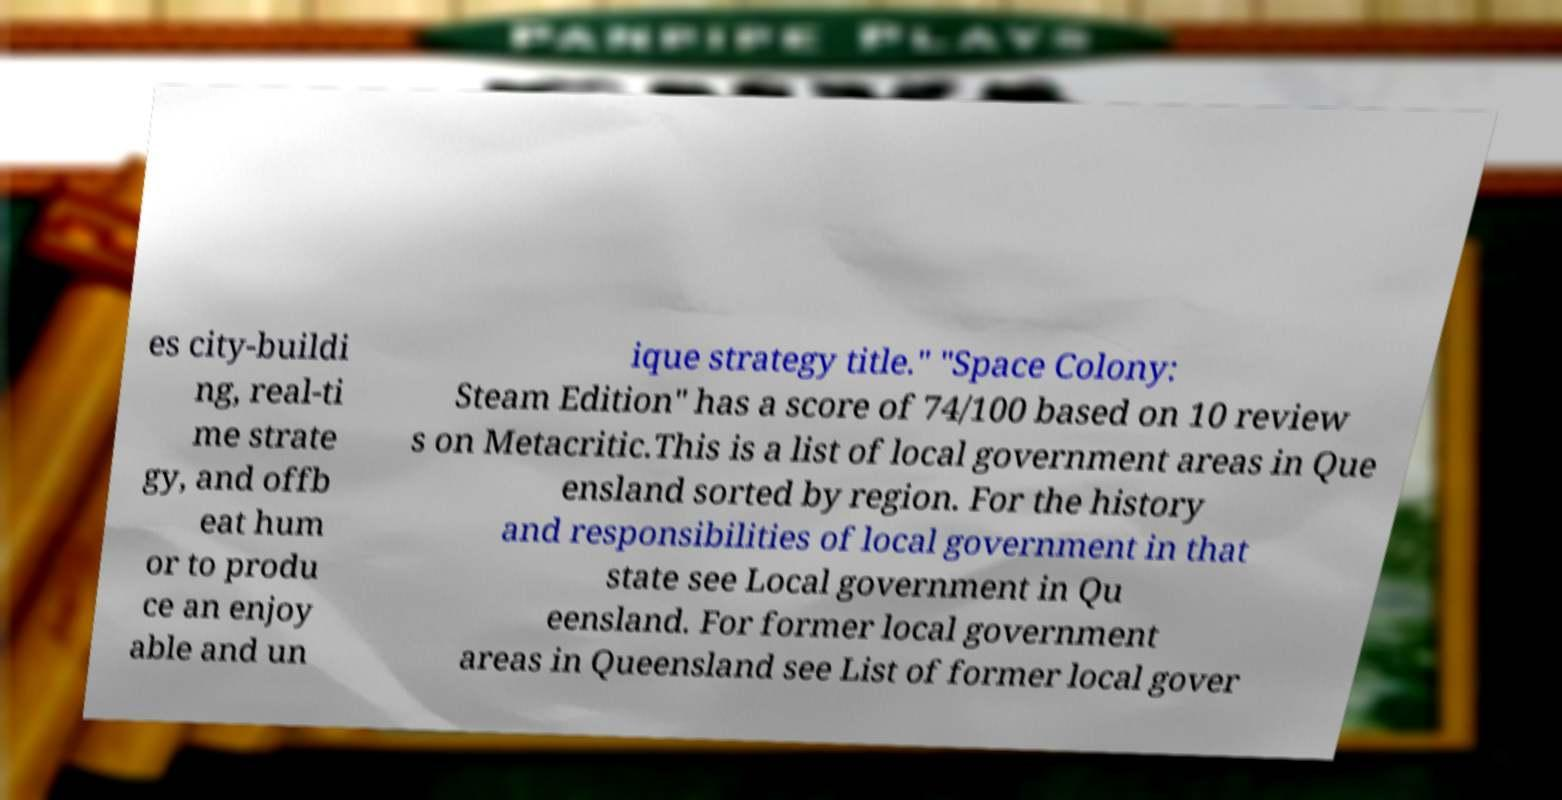Could you assist in decoding the text presented in this image and type it out clearly? es city-buildi ng, real-ti me strate gy, and offb eat hum or to produ ce an enjoy able and un ique strategy title." "Space Colony: Steam Edition" has a score of 74/100 based on 10 review s on Metacritic.This is a list of local government areas in Que ensland sorted by region. For the history and responsibilities of local government in that state see Local government in Qu eensland. For former local government areas in Queensland see List of former local gover 